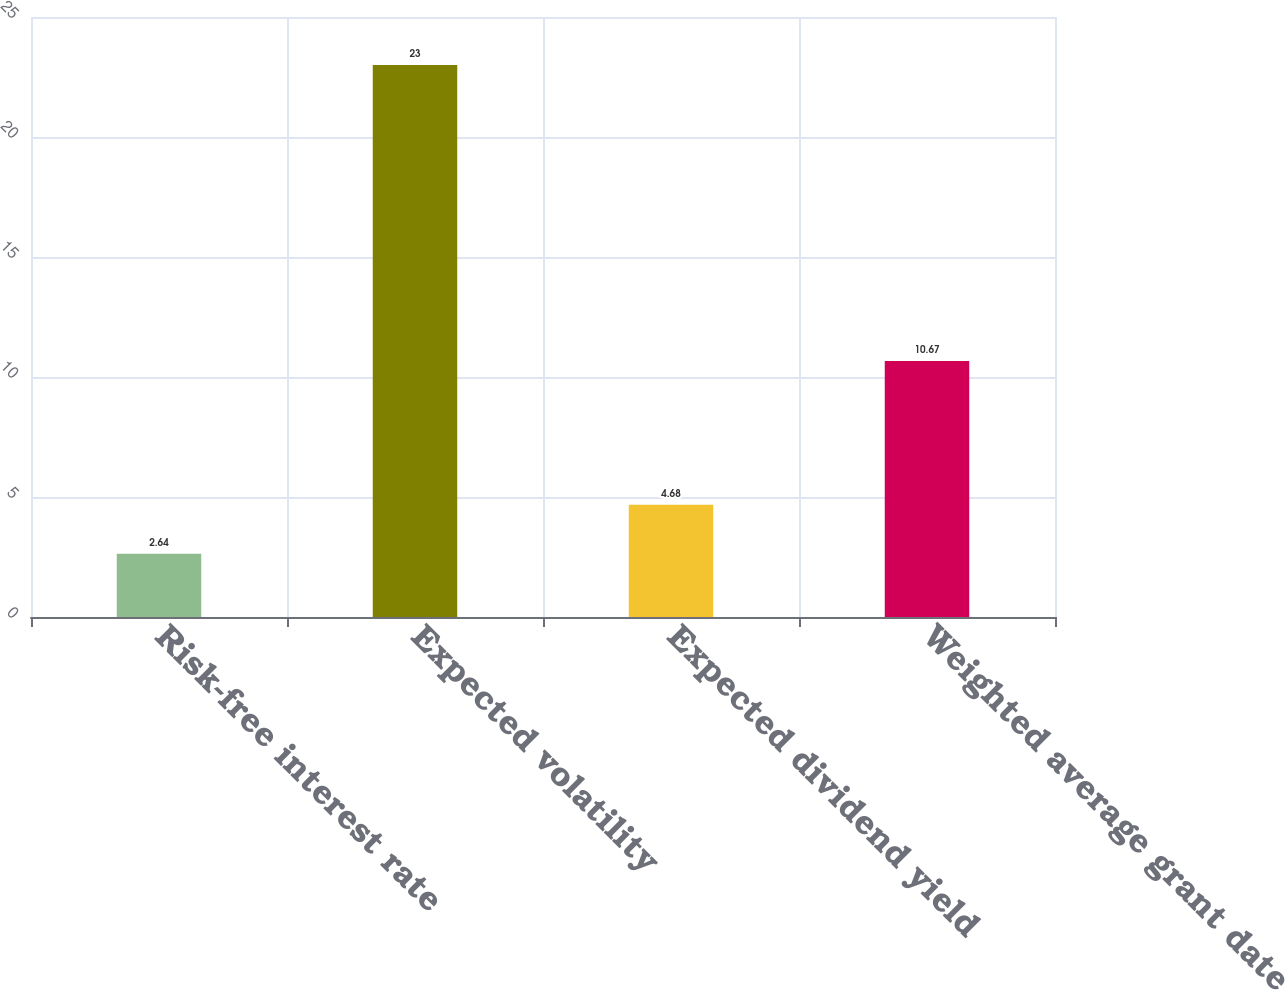<chart> <loc_0><loc_0><loc_500><loc_500><bar_chart><fcel>Risk-free interest rate<fcel>Expected volatility<fcel>Expected dividend yield<fcel>Weighted average grant date<nl><fcel>2.64<fcel>23<fcel>4.68<fcel>10.67<nl></chart> 